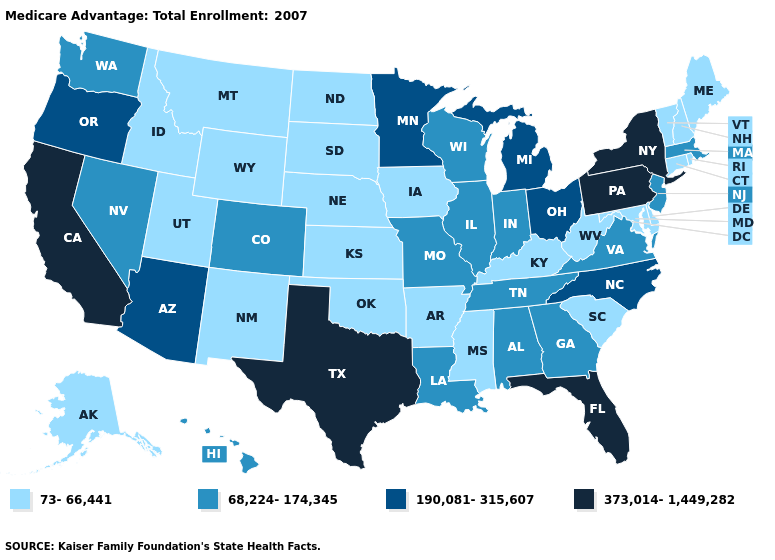What is the lowest value in the MidWest?
Short answer required. 73-66,441. What is the value of Tennessee?
Give a very brief answer. 68,224-174,345. Name the states that have a value in the range 190,081-315,607?
Be succinct. Arizona, Michigan, Minnesota, North Carolina, Ohio, Oregon. What is the highest value in states that border Utah?
Write a very short answer. 190,081-315,607. Which states hav the highest value in the West?
Short answer required. California. Name the states that have a value in the range 373,014-1,449,282?
Give a very brief answer. California, Florida, New York, Pennsylvania, Texas. Among the states that border Missouri , does Iowa have the highest value?
Keep it brief. No. Name the states that have a value in the range 73-66,441?
Write a very short answer. Alaska, Arkansas, Connecticut, Delaware, Iowa, Idaho, Kansas, Kentucky, Maryland, Maine, Mississippi, Montana, North Dakota, Nebraska, New Hampshire, New Mexico, Oklahoma, Rhode Island, South Carolina, South Dakota, Utah, Vermont, West Virginia, Wyoming. Which states have the lowest value in the West?
Answer briefly. Alaska, Idaho, Montana, New Mexico, Utah, Wyoming. What is the highest value in states that border Nevada?
Concise answer only. 373,014-1,449,282. What is the highest value in the USA?
Short answer required. 373,014-1,449,282. Does Tennessee have a higher value than Georgia?
Quick response, please. No. What is the value of Texas?
Write a very short answer. 373,014-1,449,282. How many symbols are there in the legend?
Keep it brief. 4. Does California have the highest value in the West?
Concise answer only. Yes. 